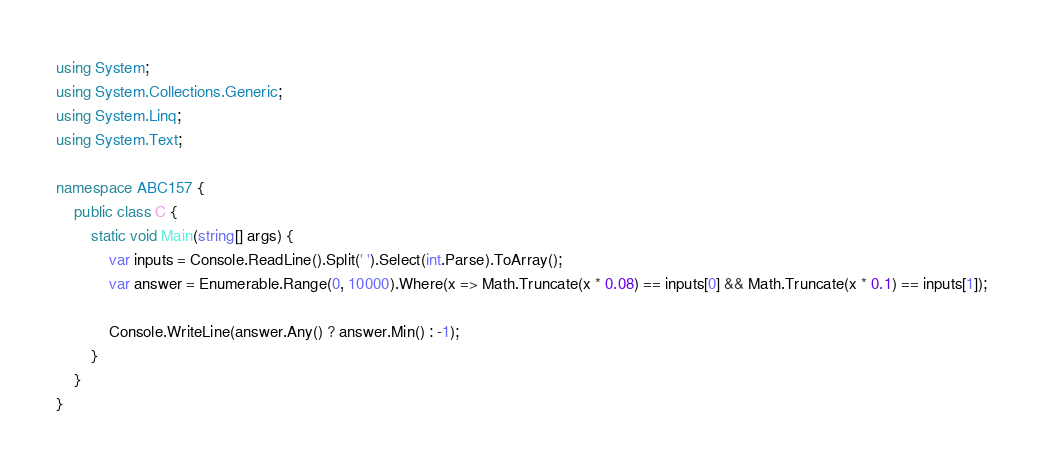Convert code to text. <code><loc_0><loc_0><loc_500><loc_500><_C#_>using System;
using System.Collections.Generic;
using System.Linq;
using System.Text;

namespace ABC157 {
    public class C {
        static void Main(string[] args) {
            var inputs = Console.ReadLine().Split(' ').Select(int.Parse).ToArray();
            var answer = Enumerable.Range(0, 10000).Where(x => Math.Truncate(x * 0.08) == inputs[0] && Math.Truncate(x * 0.1) == inputs[1]);

            Console.WriteLine(answer.Any() ? answer.Min() : -1);
        }
    }
}
</code> 